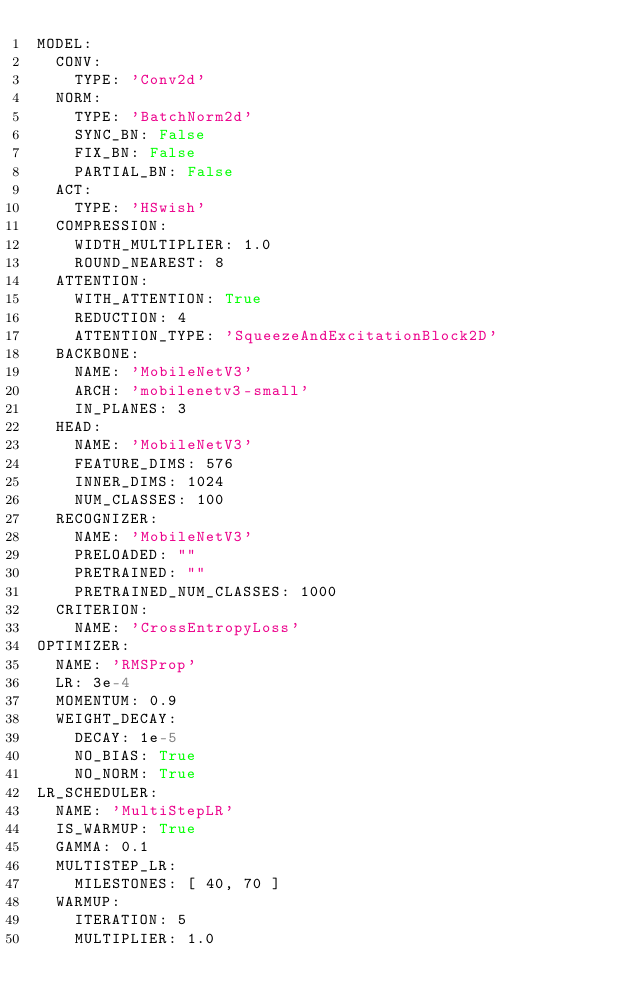Convert code to text. <code><loc_0><loc_0><loc_500><loc_500><_YAML_>MODEL:
  CONV:
    TYPE: 'Conv2d'
  NORM:
    TYPE: 'BatchNorm2d'
    SYNC_BN: False
    FIX_BN: False
    PARTIAL_BN: False
  ACT:
    TYPE: 'HSwish'
  COMPRESSION:
    WIDTH_MULTIPLIER: 1.0
    ROUND_NEAREST: 8
  ATTENTION:
    WITH_ATTENTION: True
    REDUCTION: 4
    ATTENTION_TYPE: 'SqueezeAndExcitationBlock2D'
  BACKBONE:
    NAME: 'MobileNetV3'
    ARCH: 'mobilenetv3-small'
    IN_PLANES: 3
  HEAD:
    NAME: 'MobileNetV3'
    FEATURE_DIMS: 576
    INNER_DIMS: 1024
    NUM_CLASSES: 100
  RECOGNIZER:
    NAME: 'MobileNetV3'
    PRELOADED: ""
    PRETRAINED: ""
    PRETRAINED_NUM_CLASSES: 1000
  CRITERION:
    NAME: 'CrossEntropyLoss'
OPTIMIZER:
  NAME: 'RMSProp'
  LR: 3e-4
  MOMENTUM: 0.9
  WEIGHT_DECAY:
    DECAY: 1e-5
    NO_BIAS: True
    NO_NORM: True
LR_SCHEDULER:
  NAME: 'MultiStepLR'
  IS_WARMUP: True
  GAMMA: 0.1
  MULTISTEP_LR:
    MILESTONES: [ 40, 70 ]
  WARMUP:
    ITERATION: 5
    MULTIPLIER: 1.0</code> 